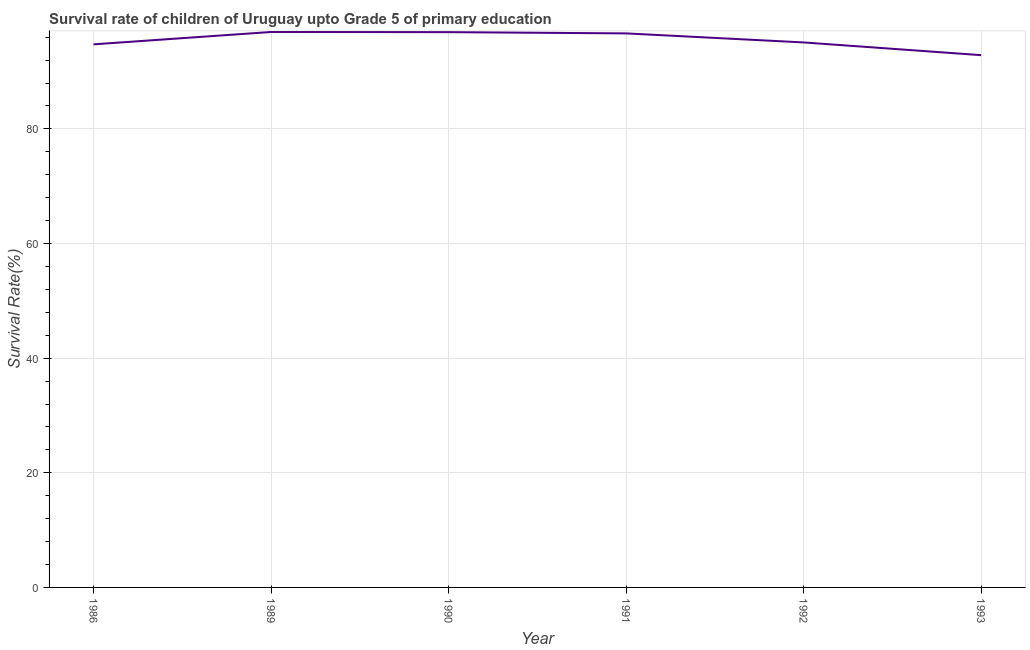What is the survival rate in 1992?
Your answer should be very brief. 95.08. Across all years, what is the maximum survival rate?
Your response must be concise. 96.9. Across all years, what is the minimum survival rate?
Make the answer very short. 92.86. In which year was the survival rate maximum?
Ensure brevity in your answer.  1989. In which year was the survival rate minimum?
Provide a succinct answer. 1993. What is the sum of the survival rate?
Offer a very short reply. 573.11. What is the difference between the survival rate in 1990 and 1991?
Your answer should be very brief. 0.22. What is the average survival rate per year?
Your answer should be very brief. 95.52. What is the median survival rate?
Your answer should be compact. 95.87. Do a majority of the years between 1986 and 1989 (inclusive) have survival rate greater than 28 %?
Ensure brevity in your answer.  Yes. What is the ratio of the survival rate in 1989 to that in 1992?
Offer a very short reply. 1.02. Is the survival rate in 1986 less than that in 1989?
Your answer should be very brief. Yes. Is the difference between the survival rate in 1986 and 1991 greater than the difference between any two years?
Make the answer very short. No. What is the difference between the highest and the second highest survival rate?
Provide a succinct answer. 0.03. What is the difference between the highest and the lowest survival rate?
Offer a terse response. 4.04. Are the values on the major ticks of Y-axis written in scientific E-notation?
Provide a succinct answer. No. What is the title of the graph?
Make the answer very short. Survival rate of children of Uruguay upto Grade 5 of primary education. What is the label or title of the X-axis?
Provide a succinct answer. Year. What is the label or title of the Y-axis?
Offer a terse response. Survival Rate(%). What is the Survival Rate(%) in 1986?
Offer a very short reply. 94.75. What is the Survival Rate(%) in 1989?
Provide a succinct answer. 96.9. What is the Survival Rate(%) in 1990?
Keep it short and to the point. 96.87. What is the Survival Rate(%) of 1991?
Give a very brief answer. 96.66. What is the Survival Rate(%) in 1992?
Your answer should be compact. 95.08. What is the Survival Rate(%) in 1993?
Ensure brevity in your answer.  92.86. What is the difference between the Survival Rate(%) in 1986 and 1989?
Keep it short and to the point. -2.16. What is the difference between the Survival Rate(%) in 1986 and 1990?
Ensure brevity in your answer.  -2.13. What is the difference between the Survival Rate(%) in 1986 and 1991?
Offer a very short reply. -1.91. What is the difference between the Survival Rate(%) in 1986 and 1992?
Keep it short and to the point. -0.33. What is the difference between the Survival Rate(%) in 1986 and 1993?
Offer a very short reply. 1.89. What is the difference between the Survival Rate(%) in 1989 and 1990?
Your response must be concise. 0.03. What is the difference between the Survival Rate(%) in 1989 and 1991?
Offer a very short reply. 0.25. What is the difference between the Survival Rate(%) in 1989 and 1992?
Ensure brevity in your answer.  1.82. What is the difference between the Survival Rate(%) in 1989 and 1993?
Your response must be concise. 4.04. What is the difference between the Survival Rate(%) in 1990 and 1991?
Provide a succinct answer. 0.22. What is the difference between the Survival Rate(%) in 1990 and 1992?
Provide a short and direct response. 1.79. What is the difference between the Survival Rate(%) in 1990 and 1993?
Provide a succinct answer. 4.01. What is the difference between the Survival Rate(%) in 1991 and 1992?
Make the answer very short. 1.58. What is the difference between the Survival Rate(%) in 1991 and 1993?
Ensure brevity in your answer.  3.8. What is the difference between the Survival Rate(%) in 1992 and 1993?
Your answer should be compact. 2.22. What is the ratio of the Survival Rate(%) in 1986 to that in 1990?
Keep it short and to the point. 0.98. What is the ratio of the Survival Rate(%) in 1986 to that in 1991?
Your answer should be very brief. 0.98. What is the ratio of the Survival Rate(%) in 1986 to that in 1993?
Provide a succinct answer. 1.02. What is the ratio of the Survival Rate(%) in 1989 to that in 1990?
Make the answer very short. 1. What is the ratio of the Survival Rate(%) in 1989 to that in 1992?
Provide a short and direct response. 1.02. What is the ratio of the Survival Rate(%) in 1989 to that in 1993?
Provide a succinct answer. 1.04. What is the ratio of the Survival Rate(%) in 1990 to that in 1993?
Offer a terse response. 1.04. What is the ratio of the Survival Rate(%) in 1991 to that in 1993?
Give a very brief answer. 1.04. 